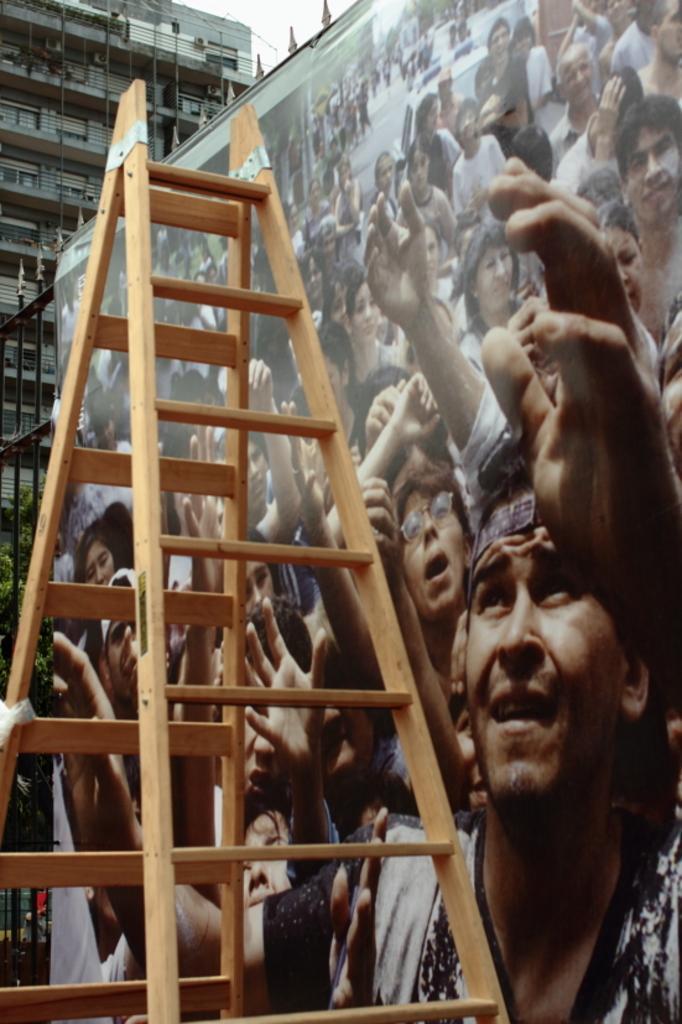Describe this image in one or two sentences. In this image we can see a building. There is a board on the fence. There are many people in the image. There is a ladder in the image. There are few plants at the left side of the image. There is a sky at the top of the image. 